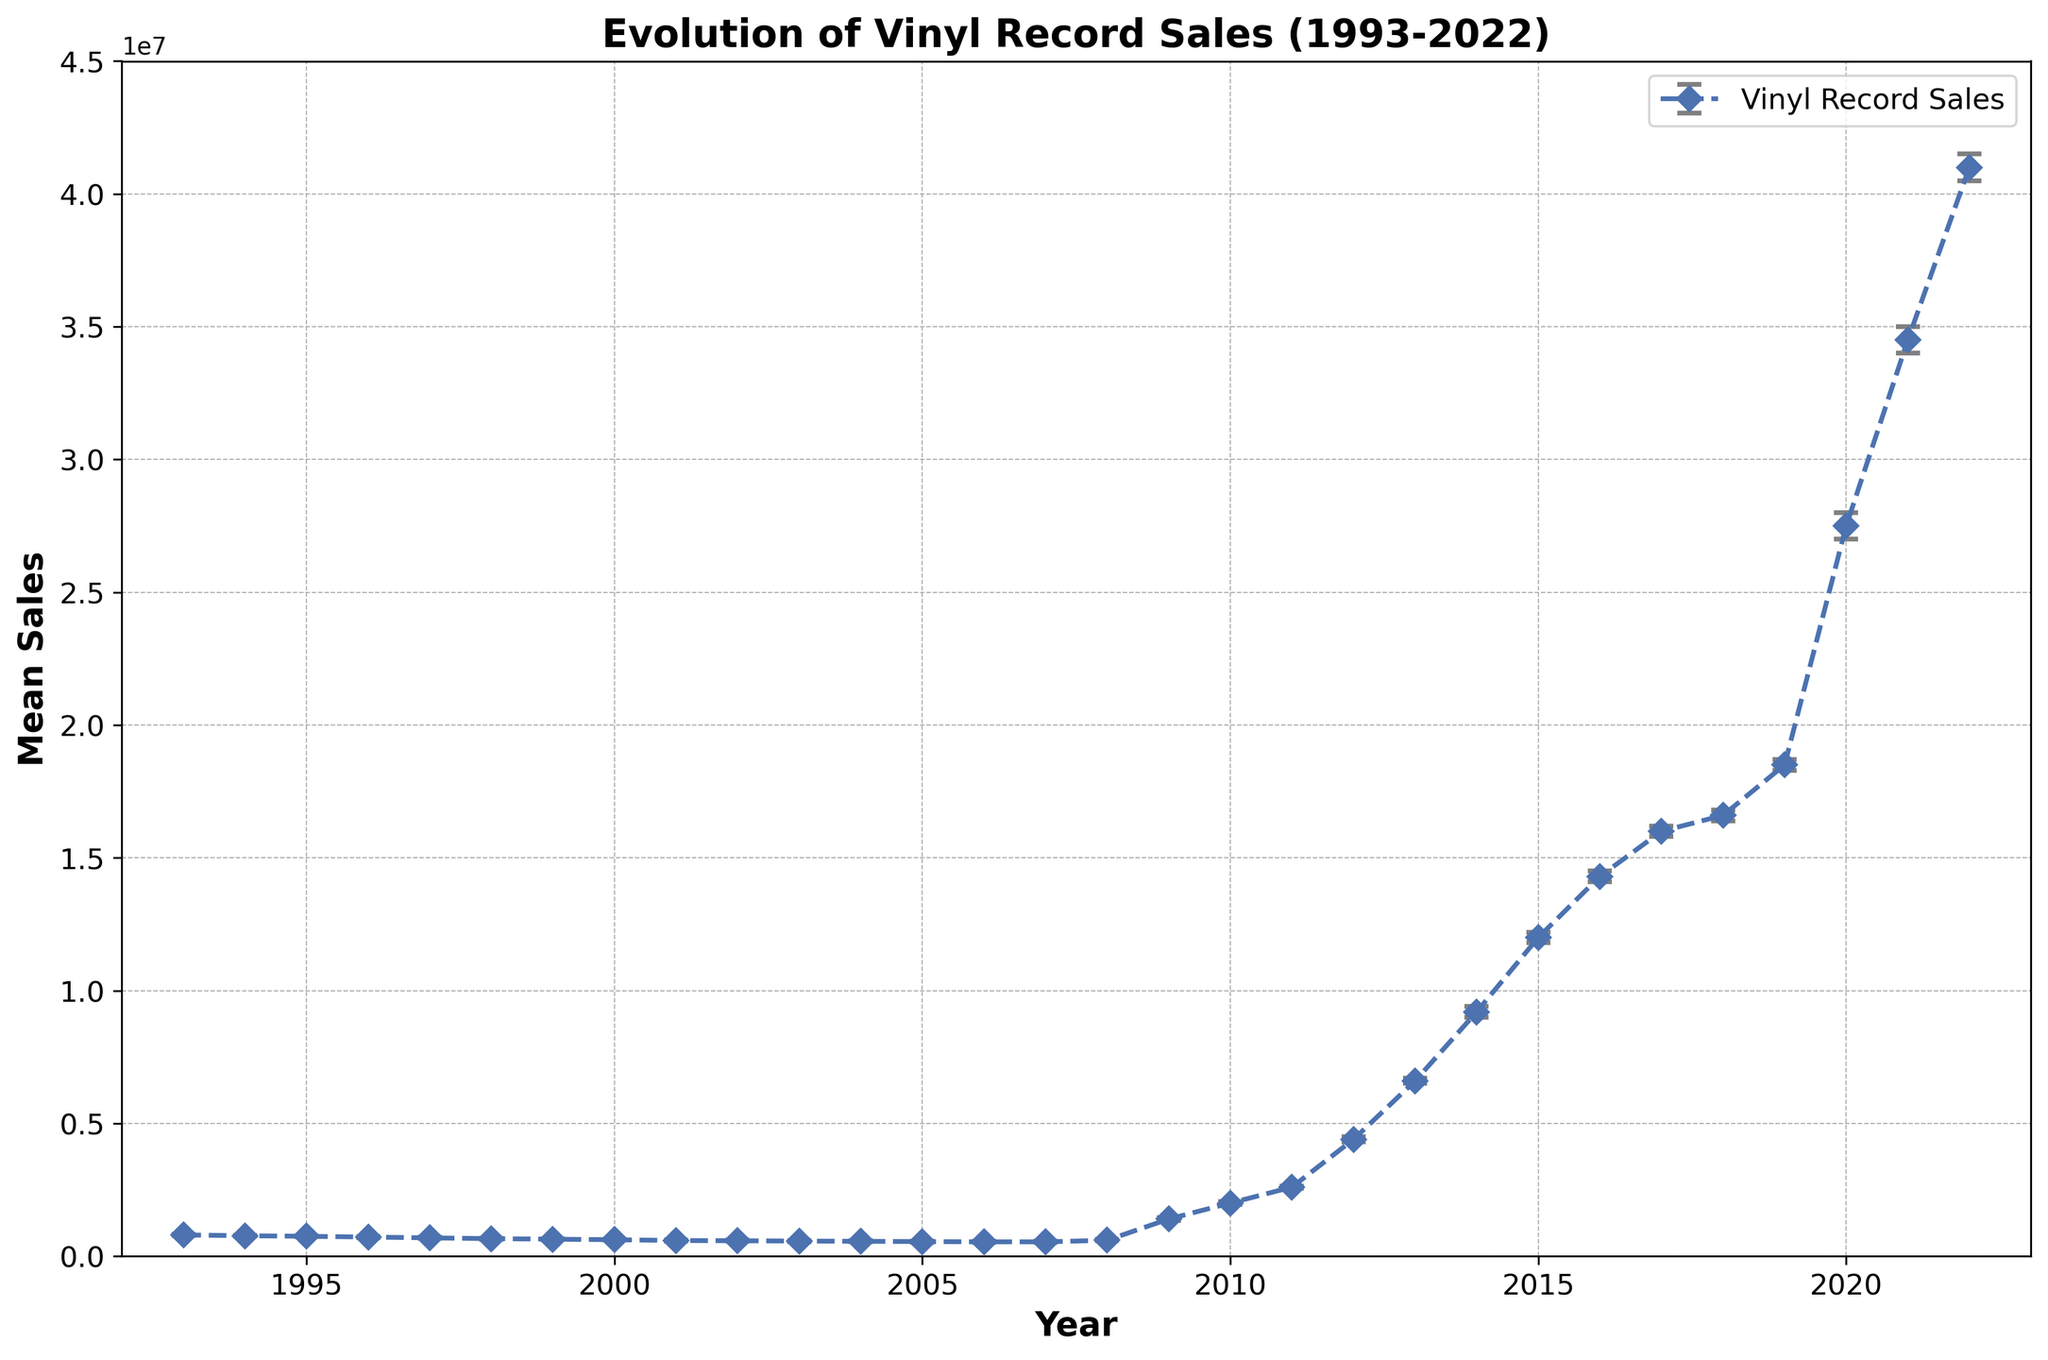How did vinyl record sales change from 1993 to 2002? Look at the mean sales figures for 1993 (800,000) and 2002 (580,000). Calculate the difference: 800,000 - 580,000 = 220,000. This represents a decrease of 220,000 units over this period.
Answer: Decreased by 220,000 Which year had the largest increase in vinyl record sales compared to the previous year? Compare the yearly increases in mean sales. From 2008 to 2009, sales increased from 600,000 to 1,400,000. Calculate the increase: 1,400,000 - 600,000 = 800,000, which is the largest increase.
Answer: 2009 In which year did vinyl record sales first exceed 10 million units? Check the mean sales and find the first year where sales exceed 10 million units. In 2015, sales were 12,000,000 units, which is the first time sales exceeded 10 million.
Answer: 2015 What is the average mean sales figure for the years 2010 to 2012? Identify the mean sales for 2010 (2,000,000), 2011 (2,600,000), and 2012 (4,400,000). Calculate the average: (2,000,000 + 2,600,000 + 4,400,000) / 3 = 3,000,000.
Answer: 3,000,000 How do the confidence intervals for 1996 and 2022 compare? In 1996, the confidence interval is between 700,000 and 740,000. In 2022, it’s between 40,500,000 and 41,500,000. The 2022 interval is significantly wider and higher.
Answer: 2022's are wider and higher Compare the mean sales in 2000 to 2022. What is the difference? Mean sales in 2000 were 620,000, while in 2022 they were 41,000,000. The difference is: 41,000,000 - 620,000 = 40,380,000.
Answer: 40,380,000 What is the median mean sales value for the entire period? List the mean sales values and find the middle value(s). Since there are 30 years, the median is the average of the 15th and 16th values: (540,000 + 600,000) / 2 = 570,000.
Answer: 570,000 In which years did vinyl record sales decrease compared to the previous year? Check each year where the mean sales value is less than the previous year. These years are 1994, 1995, 1996, 1997, 1998, 1999, 2000, 2001, 2002, 2003, 2004, and 2005.
Answer: 1994-2005 Between 2018 and 2020, what is the average increase in sales per year? Mean sales for 2018 is 16,600,000 and for 2020 is 27,500,000. The total increase is 27,500,000 - 16,600,000 = 10,900,000 over 2 years. The average increase per year: 10,900,000 / 2 = 5,450,000.
Answer: 5,450,000 Which year had the smallest confidence interval range? Calculate the range for each year. The smallest range is from 1993 with (820,000 - 780,000) = 40,000.
Answer: 1993 